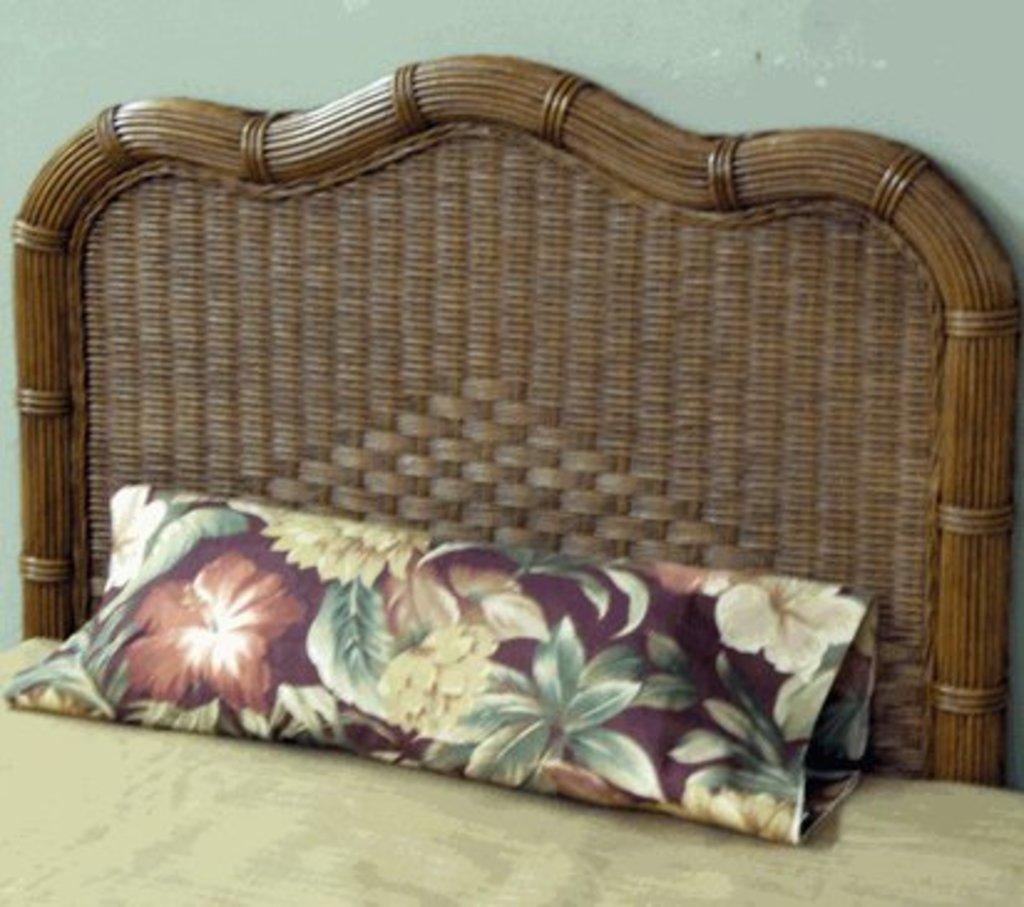Could you give a brief overview of what you see in this image? Here we can see a top side of a bed and a pillow present on it 